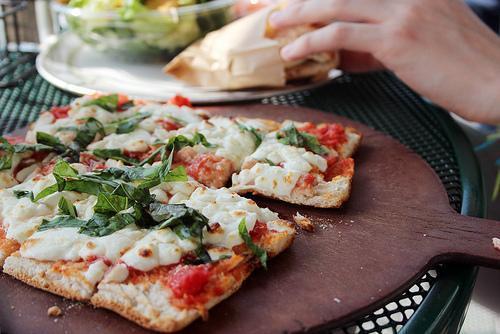How many pizzas are pictured?
Give a very brief answer. 1. 